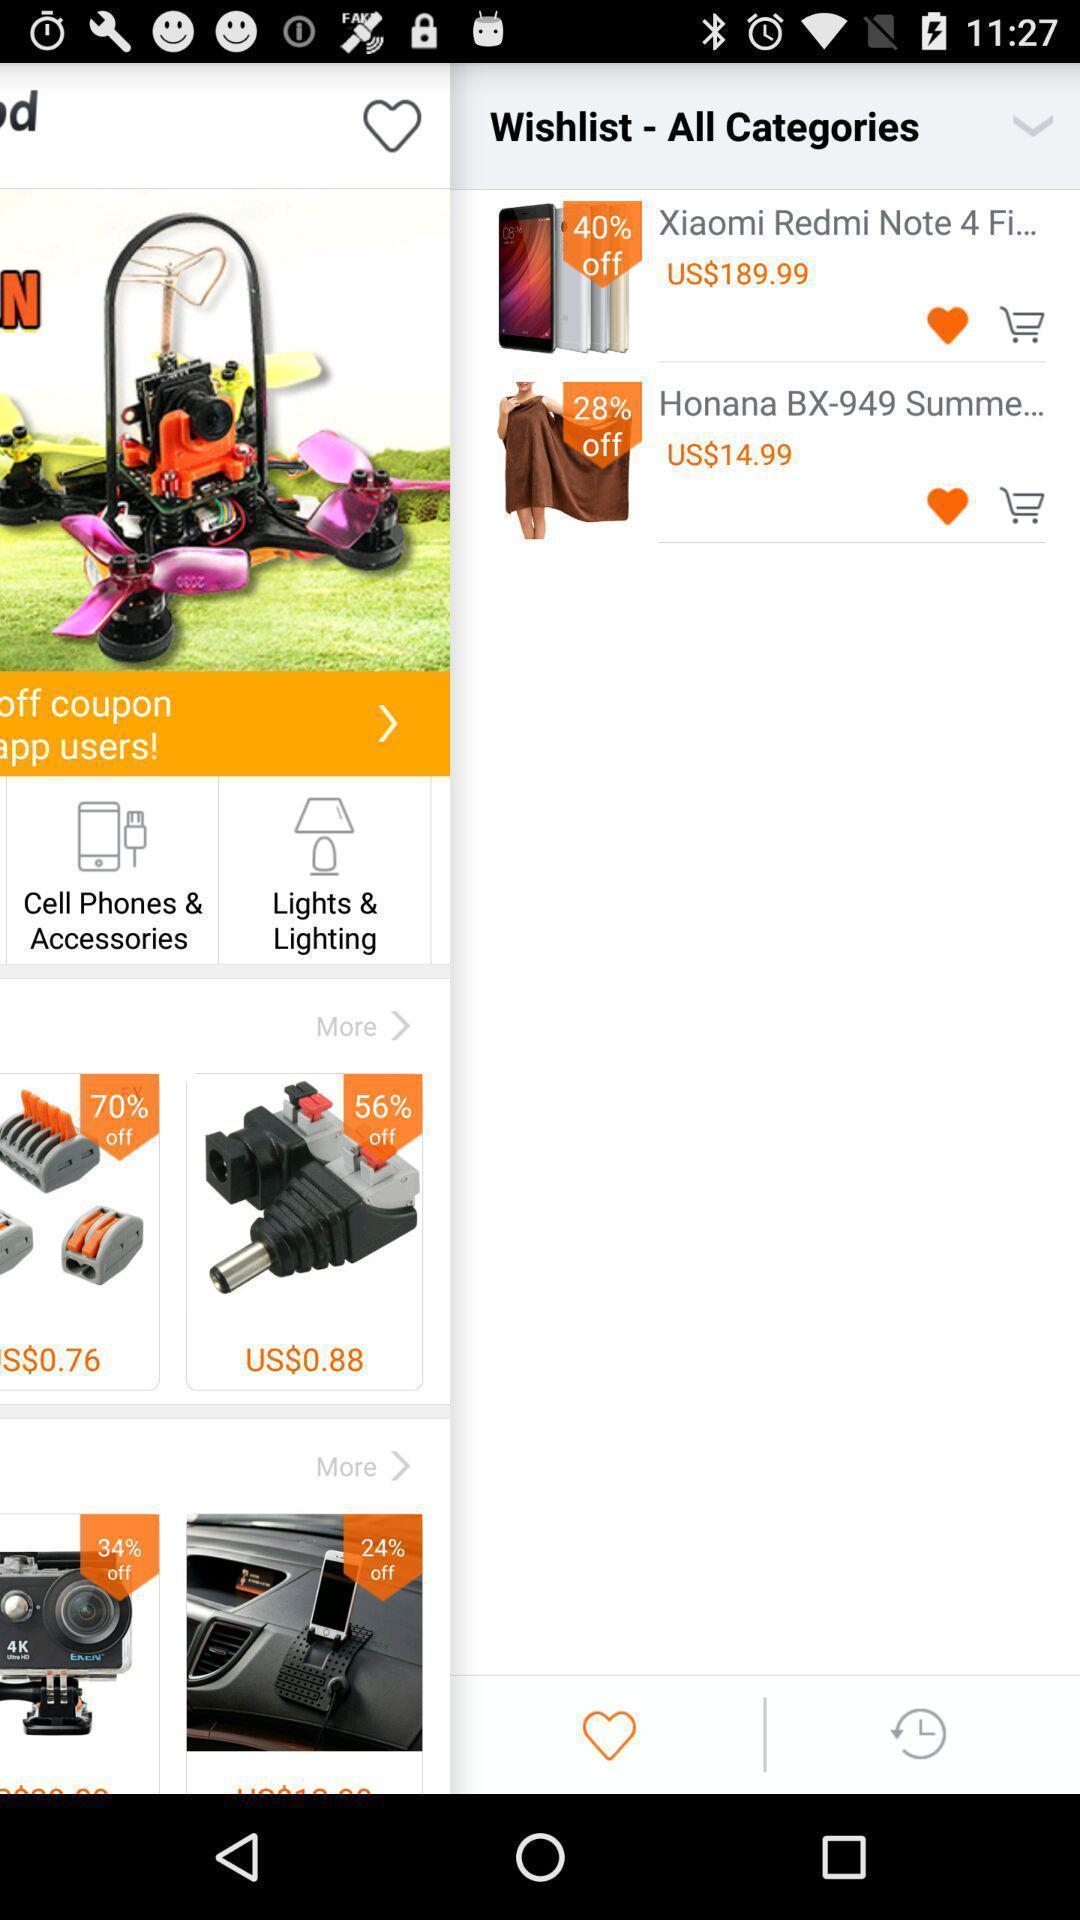Explain the elements present in this screenshot. Pop up page showing the wish list. 